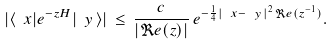<formula> <loc_0><loc_0><loc_500><loc_500>| \langle \ x | e ^ { - z H } | \ y \, \rangle | \, \leq \, \frac { c } { | \Re e ( z ) | } \, e ^ { - \frac { 1 } { 4 } | \ x - \ y \, | ^ { 2 } \, \Re e ( z ^ { - 1 } ) } .</formula> 